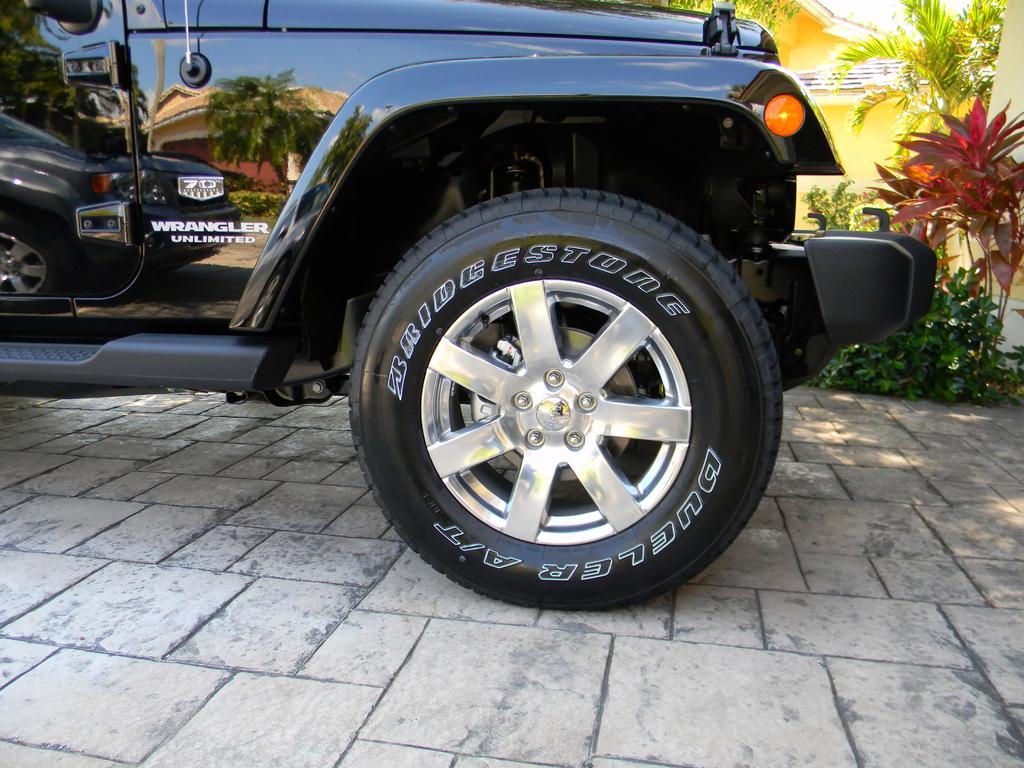Can you describe this image briefly? In this image there is a front tire of a vehicle on the surface, behind the vehicle there are trees and a building. 